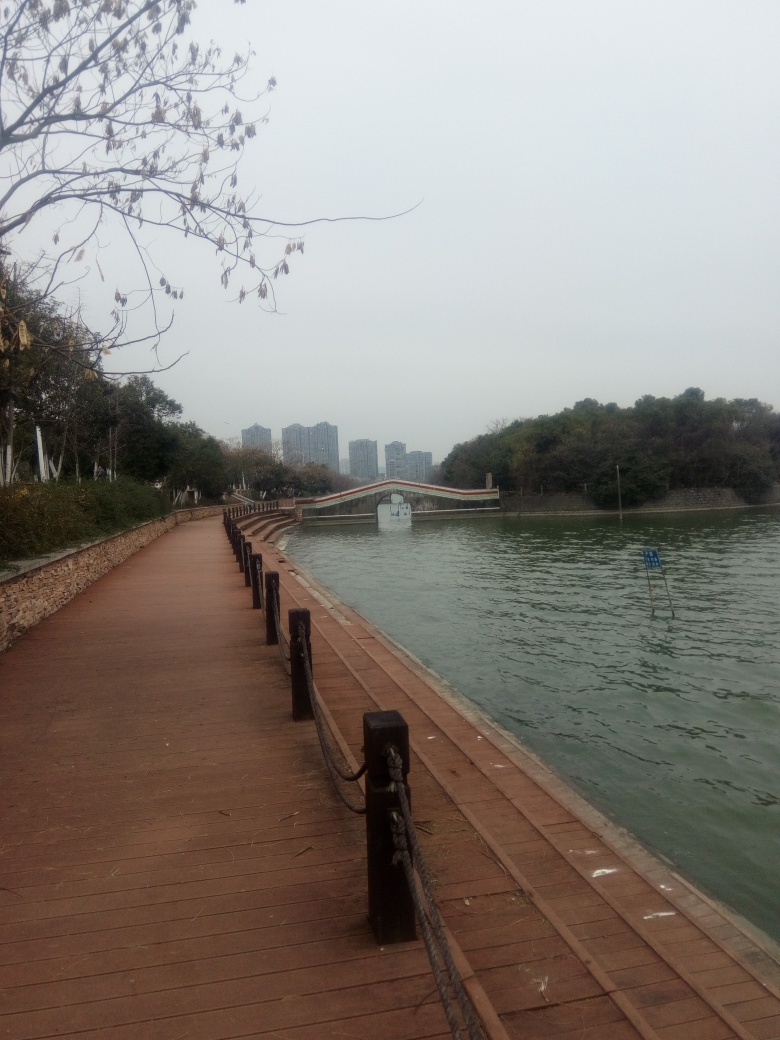Can you describe the weather conditions based on this image? The weather conditions in the image suggest an overcast or cloudy day. There is no direct sunlight visible, and the sky appears uniformly grey, which is characteristic of an overcast sky. The absence of shadows indicates that the sun is obscured by clouds. What time of day do you think it could be? Given the absence of strong shadows and a relatively flat light, it might be difficult to determine the exact time of day. However, considering the level of available ambient light, it seems to be daytime, likely late morning or afternoon. The fact that the photo does not have an orange or red hue that one would associate with sunrise or sunset supports this assumption. 